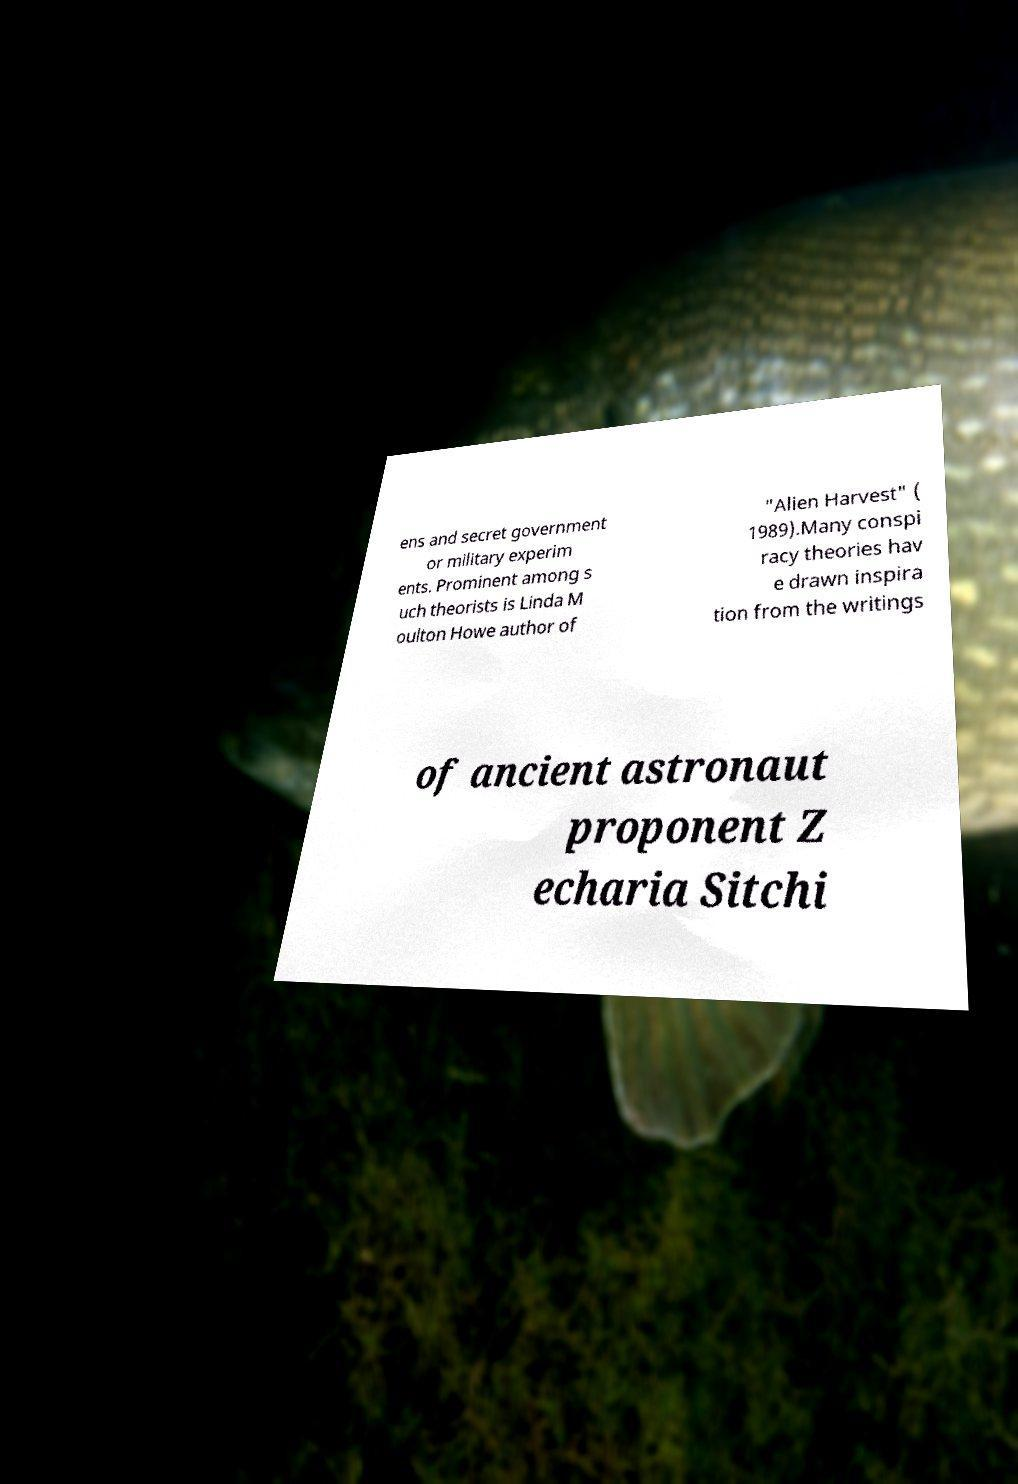There's text embedded in this image that I need extracted. Can you transcribe it verbatim? ens and secret government or military experim ents. Prominent among s uch theorists is Linda M oulton Howe author of "Alien Harvest" ( 1989).Many conspi racy theories hav e drawn inspira tion from the writings of ancient astronaut proponent Z echaria Sitchi 